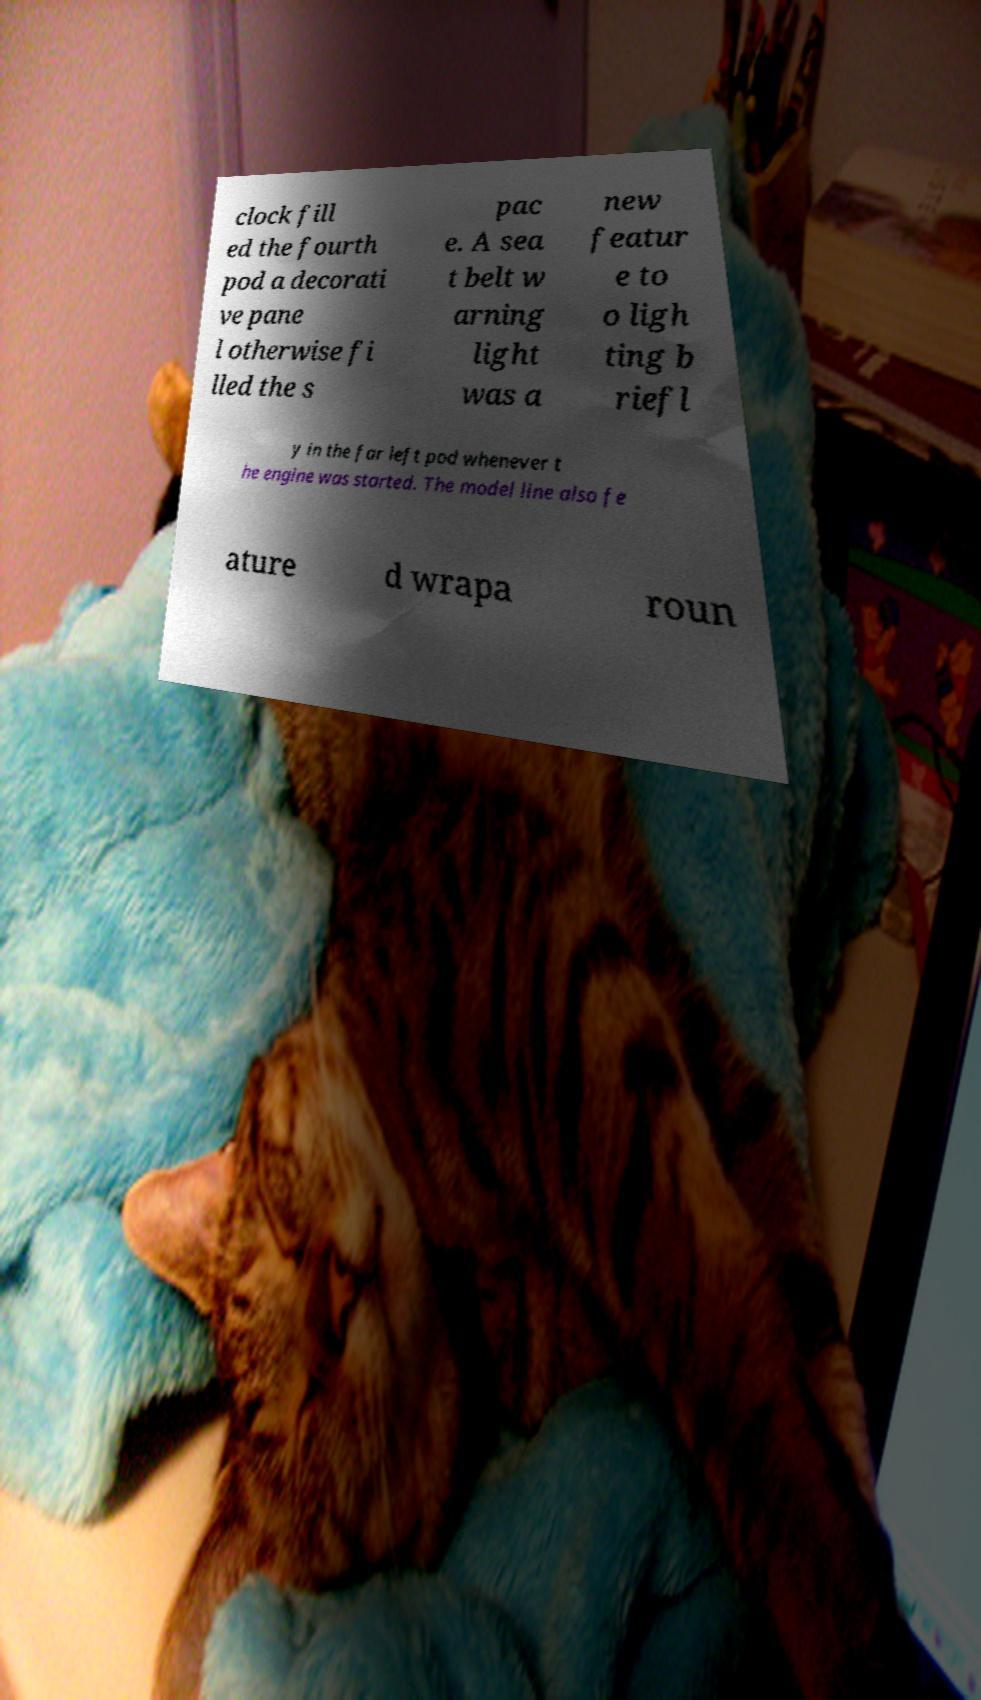There's text embedded in this image that I need extracted. Can you transcribe it verbatim? clock fill ed the fourth pod a decorati ve pane l otherwise fi lled the s pac e. A sea t belt w arning light was a new featur e to o ligh ting b riefl y in the far left pod whenever t he engine was started. The model line also fe ature d wrapa roun 